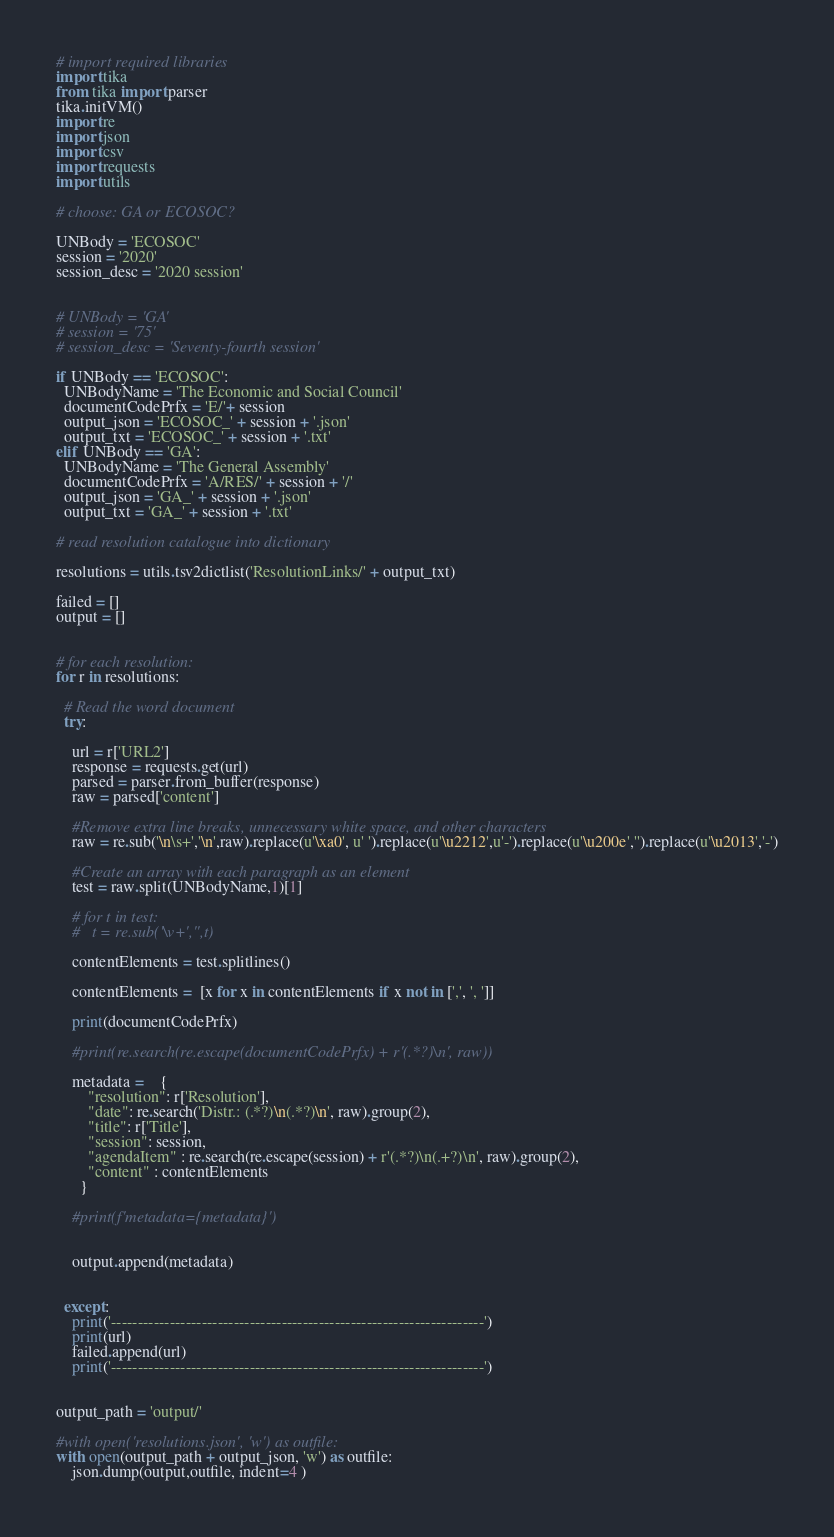<code> <loc_0><loc_0><loc_500><loc_500><_Python_># import required libraries
import tika
from tika import parser
tika.initVM()
import re
import json
import csv
import requests
import utils

# choose: GA or ECOSOC?

UNBody = 'ECOSOC'
session = '2020' 
session_desc = '2020 session'


# UNBody = 'GA'
# session = '75' 
# session_desc = 'Seventy-fourth session'

if UNBody == 'ECOSOC':
  UNBodyName = 'The Economic and Social Council'
  documentCodePrfx = 'E/'+ session
  output_json = 'ECOSOC_' + session + '.json'
  output_txt = 'ECOSOC_' + session + '.txt'  
elif UNBody == 'GA':
  UNBodyName = 'The General Assembly'
  documentCodePrfx = 'A/RES/' + session + '/'
  output_json = 'GA_' + session + '.json'
  output_txt = 'GA_' + session + '.txt'  

# read resolution catalogue into dictionary

resolutions = utils.tsv2dictlist('ResolutionLinks/' + output_txt)

failed = []
output = []


# for each resolution:
for r in resolutions:
  
  # Read the word document
  try:

    url = r['URL2']
    response = requests.get(url)
    parsed = parser.from_buffer(response)
    raw = parsed['content']

    #Remove extra line breaks, unnecessary white space, and other characters
    raw = re.sub('\n\s+','\n',raw).replace(u'\xa0', u' ').replace(u'\u2212',u'-').replace(u'\u200e','').replace(u'\u2013','-')

    #Create an array with each paragraph as an element
    test = raw.split(UNBodyName,1)[1]

    # for t in test:
    #   t = re.sub('\v+','',t)

    contentElements = test.splitlines()

    contentElements =  [x for x in contentElements if x not in [',', ', ']]

    print(documentCodePrfx)

    #print(re.search(re.escape(documentCodePrfx) + r'(.*?)\n', raw))

    metadata =	{
        "resolution": r['Resolution'],
        "date": re.search('Distr.: (.*?)\n(.*?)\n', raw).group(2),
        "title": r['Title'],
        "session": session,
        "agendaItem" : re.search(re.escape(session) + r'(.*?)\n(.+?)\n', raw).group(2),
        "content" : contentElements
      }

    #print(f'metadata={metadata}')


    output.append(metadata)
    

  except:
    print('----------------------------------------------------------------------')
    print(url)
    failed.append(url)
    print('----------------------------------------------------------------------')


output_path = 'output/'

#with open('resolutions.json', 'w') as outfile:
with open(output_path + output_json, 'w') as outfile:
    json.dump(output,outfile, indent=4 )    

</code> 